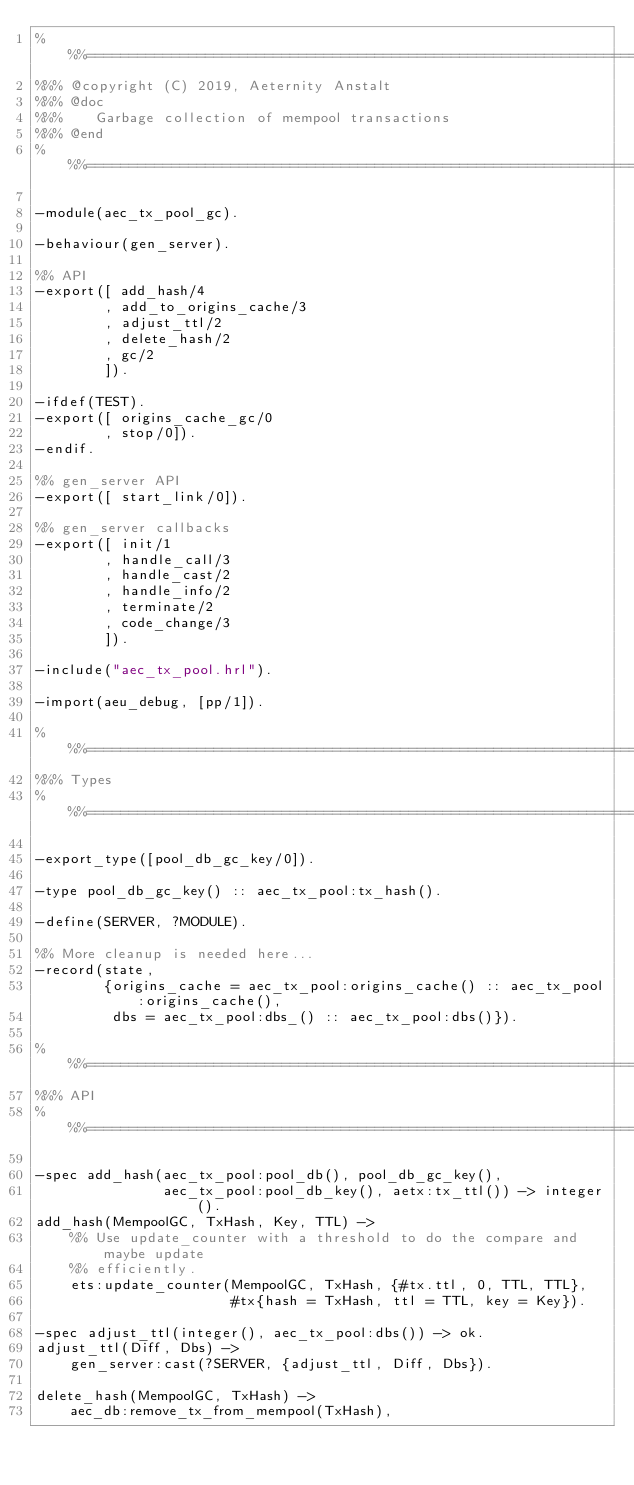Convert code to text. <code><loc_0><loc_0><loc_500><loc_500><_Erlang_>%%%=============================================================================
%%% @copyright (C) 2019, Aeternity Anstalt
%%% @doc
%%%    Garbage collection of mempool transactions
%%% @end
%%%=============================================================================

-module(aec_tx_pool_gc).

-behaviour(gen_server).

%% API
-export([ add_hash/4
        , add_to_origins_cache/3
        , adjust_ttl/2
        , delete_hash/2
        , gc/2
        ]).

-ifdef(TEST).
-export([ origins_cache_gc/0
        , stop/0]).
-endif.

%% gen_server API
-export([ start_link/0]).

%% gen_server callbacks
-export([ init/1
        , handle_call/3
        , handle_cast/2
        , handle_info/2
        , terminate/2
        , code_change/3
        ]).

-include("aec_tx_pool.hrl").

-import(aeu_debug, [pp/1]).

%%%===================================================================
%%% Types
%%%===================================================================

-export_type([pool_db_gc_key/0]).

-type pool_db_gc_key() :: aec_tx_pool:tx_hash().

-define(SERVER, ?MODULE).

%% More cleanup is needed here...
-record(state,
        {origins_cache = aec_tx_pool:origins_cache() :: aec_tx_pool:origins_cache(),
         dbs = aec_tx_pool:dbs_() :: aec_tx_pool:dbs()}).

%%%===================================================================
%%% API
%%%===================================================================

-spec add_hash(aec_tx_pool:pool_db(), pool_db_gc_key(),
               aec_tx_pool:pool_db_key(), aetx:tx_ttl()) -> integer().
add_hash(MempoolGC, TxHash, Key, TTL) ->
    %% Use update_counter with a threshold to do the compare and maybe update
    %% efficiently.
    ets:update_counter(MempoolGC, TxHash, {#tx.ttl, 0, TTL, TTL},
                       #tx{hash = TxHash, ttl = TTL, key = Key}).

-spec adjust_ttl(integer(), aec_tx_pool:dbs()) -> ok.
adjust_ttl(Diff, Dbs) ->
    gen_server:cast(?SERVER, {adjust_ttl, Diff, Dbs}).

delete_hash(MempoolGC, TxHash) ->
    aec_db:remove_tx_from_mempool(TxHash),</code> 